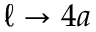<formula> <loc_0><loc_0><loc_500><loc_500>\ell \to 4 a</formula> 